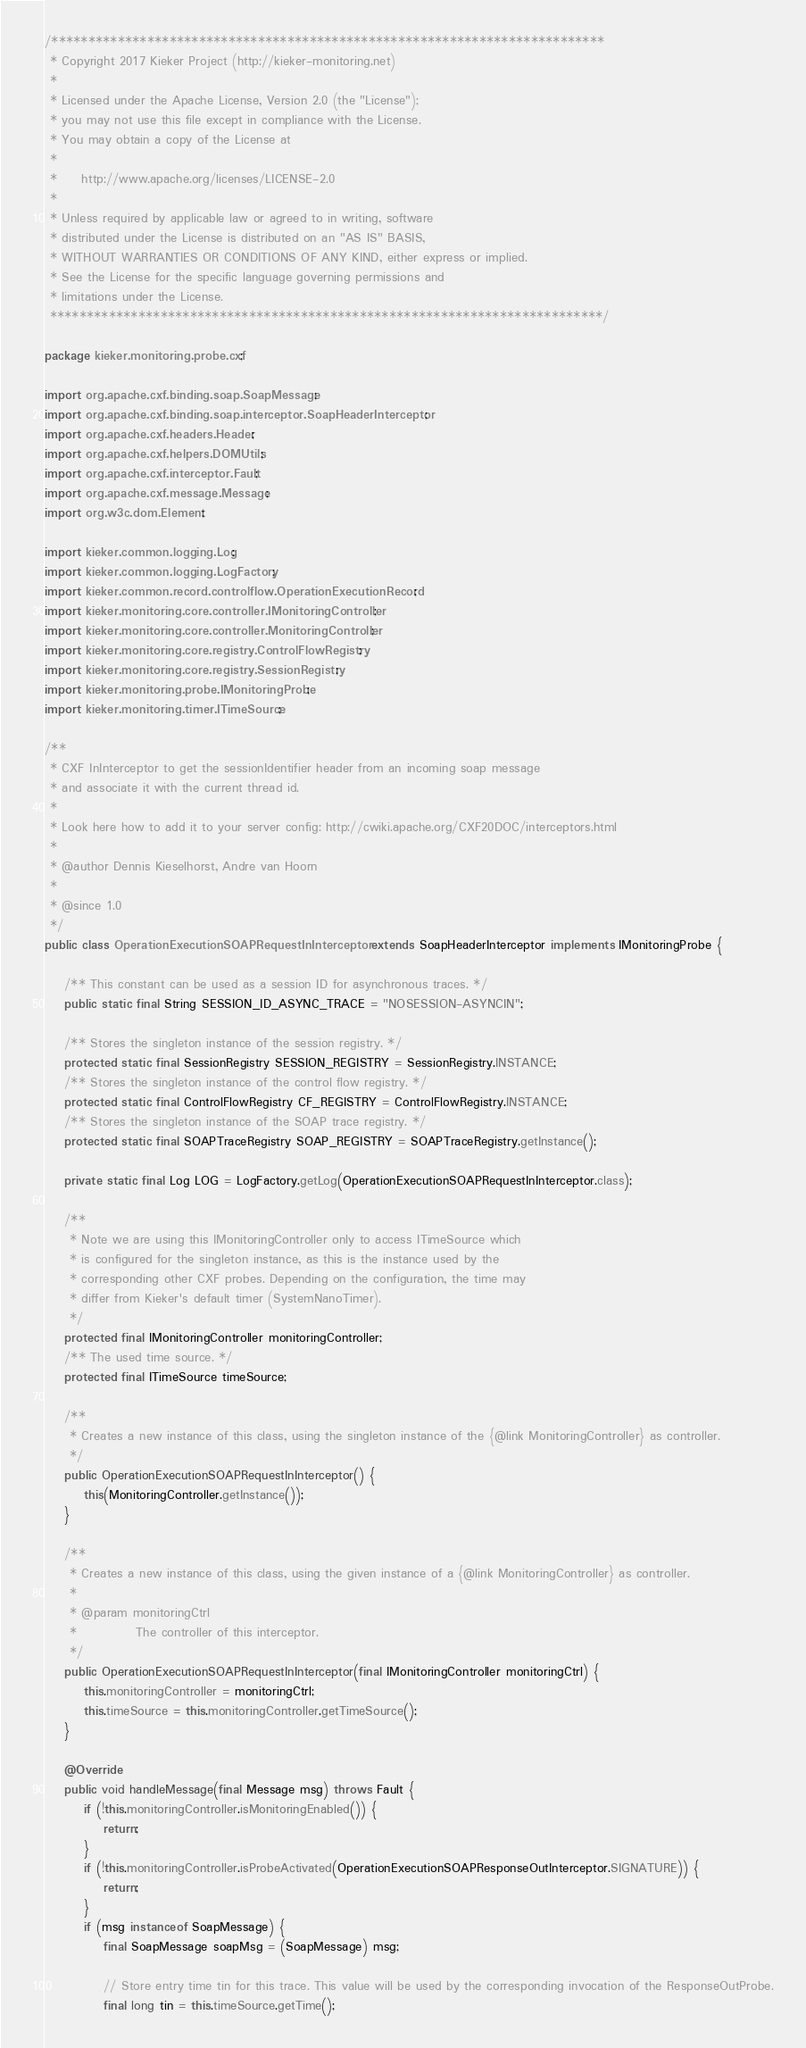Convert code to text. <code><loc_0><loc_0><loc_500><loc_500><_Java_>/***************************************************************************
 * Copyright 2017 Kieker Project (http://kieker-monitoring.net)
 *
 * Licensed under the Apache License, Version 2.0 (the "License");
 * you may not use this file except in compliance with the License.
 * You may obtain a copy of the License at
 *
 *     http://www.apache.org/licenses/LICENSE-2.0
 *
 * Unless required by applicable law or agreed to in writing, software
 * distributed under the License is distributed on an "AS IS" BASIS,
 * WITHOUT WARRANTIES OR CONDITIONS OF ANY KIND, either express or implied.
 * See the License for the specific language governing permissions and
 * limitations under the License.
 ***************************************************************************/

package kieker.monitoring.probe.cxf;

import org.apache.cxf.binding.soap.SoapMessage;
import org.apache.cxf.binding.soap.interceptor.SoapHeaderInterceptor;
import org.apache.cxf.headers.Header;
import org.apache.cxf.helpers.DOMUtils;
import org.apache.cxf.interceptor.Fault;
import org.apache.cxf.message.Message;
import org.w3c.dom.Element;

import kieker.common.logging.Log;
import kieker.common.logging.LogFactory;
import kieker.common.record.controlflow.OperationExecutionRecord;
import kieker.monitoring.core.controller.IMonitoringController;
import kieker.monitoring.core.controller.MonitoringController;
import kieker.monitoring.core.registry.ControlFlowRegistry;
import kieker.monitoring.core.registry.SessionRegistry;
import kieker.monitoring.probe.IMonitoringProbe;
import kieker.monitoring.timer.ITimeSource;

/**
 * CXF InInterceptor to get the sessionIdentifier header from an incoming soap message
 * and associate it with the current thread id.
 * 
 * Look here how to add it to your server config: http://cwiki.apache.org/CXF20DOC/interceptors.html
 * 
 * @author Dennis Kieselhorst, Andre van Hoorn
 * 
 * @since 1.0
 */
public class OperationExecutionSOAPRequestInInterceptor extends SoapHeaderInterceptor implements IMonitoringProbe {

	/** This constant can be used as a session ID for asynchronous traces. */
	public static final String SESSION_ID_ASYNC_TRACE = "NOSESSION-ASYNCIN";

	/** Stores the singleton instance of the session registry. */
	protected static final SessionRegistry SESSION_REGISTRY = SessionRegistry.INSTANCE;
	/** Stores the singleton instance of the control flow registry. */
	protected static final ControlFlowRegistry CF_REGISTRY = ControlFlowRegistry.INSTANCE;
	/** Stores the singleton instance of the SOAP trace registry. */
	protected static final SOAPTraceRegistry SOAP_REGISTRY = SOAPTraceRegistry.getInstance();

	private static final Log LOG = LogFactory.getLog(OperationExecutionSOAPRequestInInterceptor.class);

	/**
	 * Note we are using this IMonitoringController only to access ITimeSource which
	 * is configured for the singleton instance, as this is the instance used by the
	 * corresponding other CXF probes. Depending on the configuration, the time may
	 * differ from Kieker's default timer (SystemNanoTimer).
	 */
	protected final IMonitoringController monitoringController;
	/** The used time source. */
	protected final ITimeSource timeSource;

	/**
	 * Creates a new instance of this class, using the singleton instance of the {@link MonitoringController} as controller.
	 */
	public OperationExecutionSOAPRequestInInterceptor() {
		this(MonitoringController.getInstance());
	}

	/**
	 * Creates a new instance of this class, using the given instance of a {@link MonitoringController} as controller.
	 * 
	 * @param monitoringCtrl
	 *            The controller of this interceptor.
	 */
	public OperationExecutionSOAPRequestInInterceptor(final IMonitoringController monitoringCtrl) {
		this.monitoringController = monitoringCtrl;
		this.timeSource = this.monitoringController.getTimeSource();
	}

	@Override
	public void handleMessage(final Message msg) throws Fault {
		if (!this.monitoringController.isMonitoringEnabled()) {
			return;
		}
		if (!this.monitoringController.isProbeActivated(OperationExecutionSOAPResponseOutInterceptor.SIGNATURE)) {
			return;
		}
		if (msg instanceof SoapMessage) {
			final SoapMessage soapMsg = (SoapMessage) msg;

			// Store entry time tin for this trace. This value will be used by the corresponding invocation of the ResponseOutProbe.
			final long tin = this.timeSource.getTime();</code> 